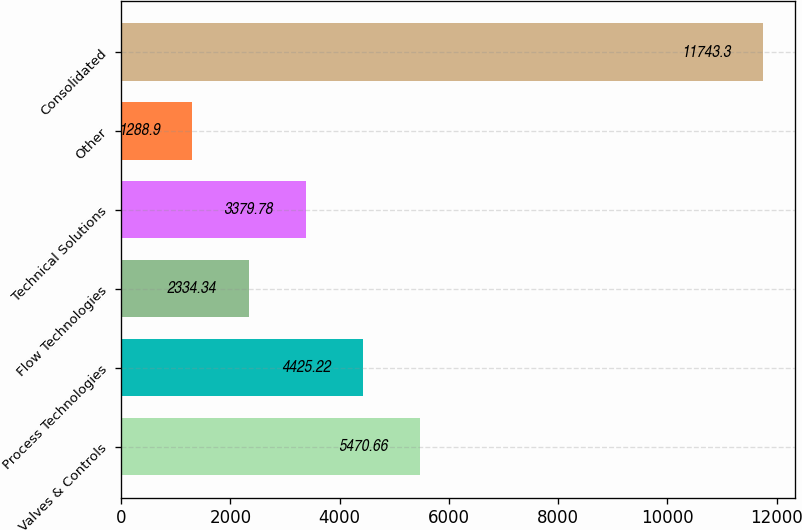<chart> <loc_0><loc_0><loc_500><loc_500><bar_chart><fcel>Valves & Controls<fcel>Process Technologies<fcel>Flow Technologies<fcel>Technical Solutions<fcel>Other<fcel>Consolidated<nl><fcel>5470.66<fcel>4425.22<fcel>2334.34<fcel>3379.78<fcel>1288.9<fcel>11743.3<nl></chart> 